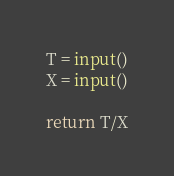<code> <loc_0><loc_0><loc_500><loc_500><_Python_>T = input()
X = input()

return T/X</code> 